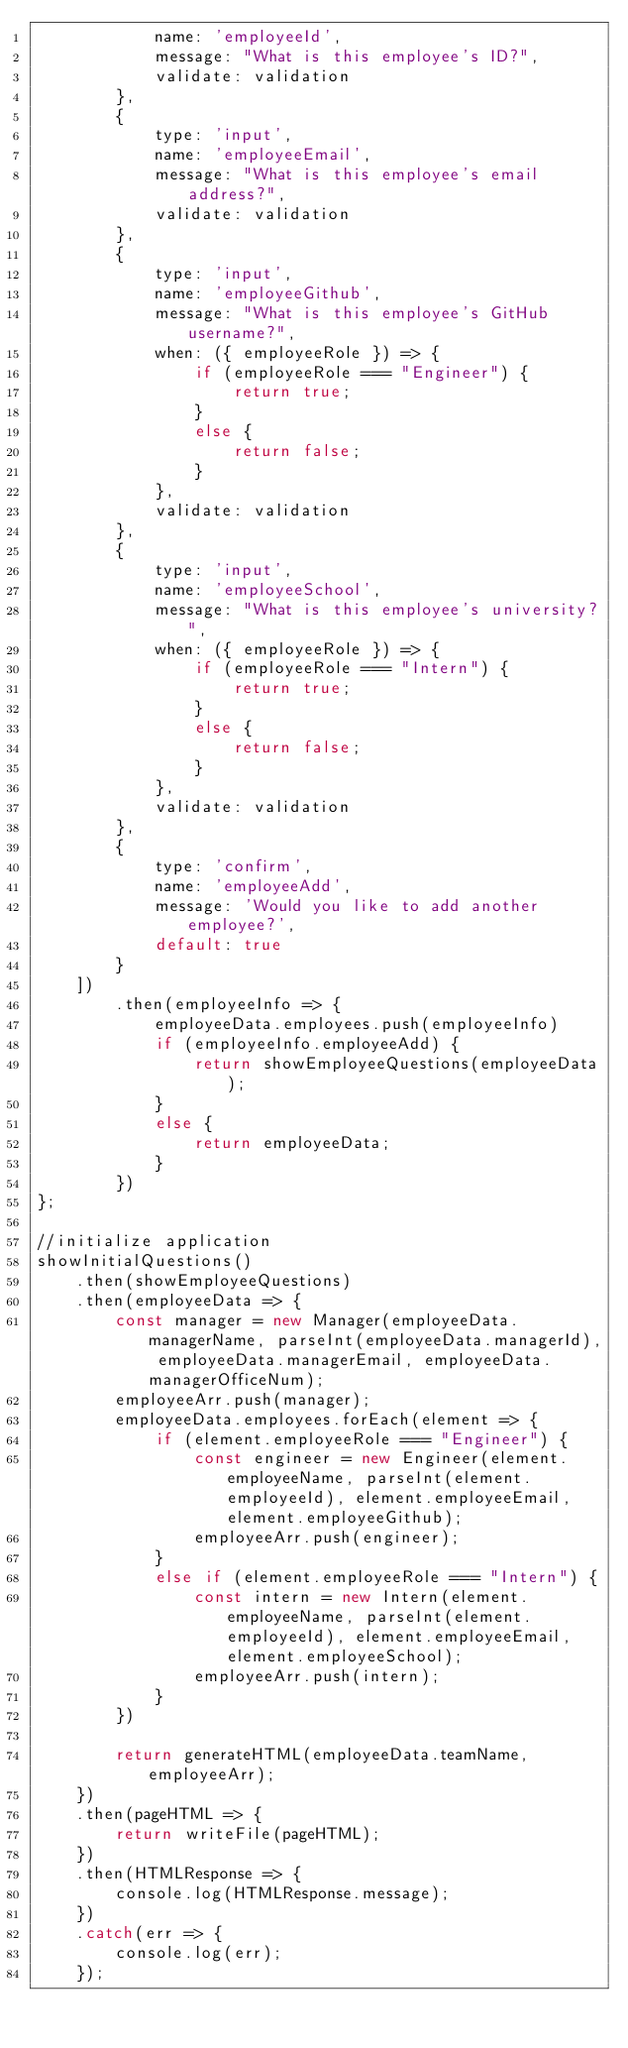Convert code to text. <code><loc_0><loc_0><loc_500><loc_500><_JavaScript_>            name: 'employeeId',
            message: "What is this employee's ID?",
            validate: validation
        },
        {
            type: 'input',
            name: 'employeeEmail',
            message: "What is this employee's email address?",
            validate: validation
        },
        {
            type: 'input',
            name: 'employeeGithub',
            message: "What is this employee's GitHub username?",
            when: ({ employeeRole }) => {
                if (employeeRole === "Engineer") {
                    return true;
                }
                else {
                    return false;
                }
            },
            validate: validation
        },
        {
            type: 'input',
            name: 'employeeSchool',
            message: "What is this employee's university?",
            when: ({ employeeRole }) => {
                if (employeeRole === "Intern") {
                    return true;
                }
                else {
                    return false;
                }
            },
            validate: validation
        },
        {
            type: 'confirm',
            name: 'employeeAdd',
            message: 'Would you like to add another employee?',
            default: true
        }
    ])
        .then(employeeInfo => {
            employeeData.employees.push(employeeInfo)
            if (employeeInfo.employeeAdd) {
                return showEmployeeQuestions(employeeData);
            }
            else {
                return employeeData;
            }
        })
};

//initialize application
showInitialQuestions()
    .then(showEmployeeQuestions)
    .then(employeeData => {
        const manager = new Manager(employeeData.managerName, parseInt(employeeData.managerId), employeeData.managerEmail, employeeData.managerOfficeNum);
        employeeArr.push(manager);
        employeeData.employees.forEach(element => {
            if (element.employeeRole === "Engineer") {
                const engineer = new Engineer(element.employeeName, parseInt(element.employeeId), element.employeeEmail, element.employeeGithub);
                employeeArr.push(engineer);
            }
            else if (element.employeeRole === "Intern") {
                const intern = new Intern(element.employeeName, parseInt(element.employeeId), element.employeeEmail, element.employeeSchool);
                employeeArr.push(intern);
            }
        })

        return generateHTML(employeeData.teamName, employeeArr);
    })
    .then(pageHTML => {
        return writeFile(pageHTML);
    })
    .then(HTMLResponse => {
        console.log(HTMLResponse.message);
    })
    .catch(err => {
        console.log(err);
    });</code> 